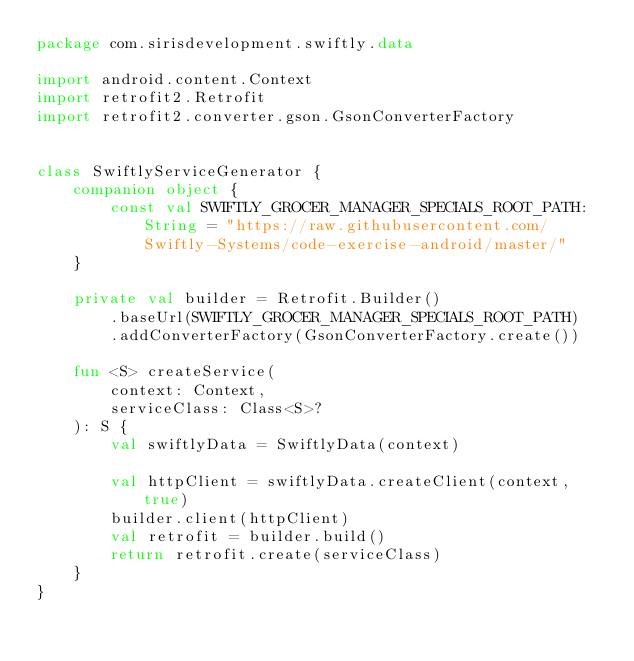Convert code to text. <code><loc_0><loc_0><loc_500><loc_500><_Kotlin_>package com.sirisdevelopment.swiftly.data

import android.content.Context
import retrofit2.Retrofit
import retrofit2.converter.gson.GsonConverterFactory


class SwiftlyServiceGenerator {
    companion object {
        const val SWIFTLY_GROCER_MANAGER_SPECIALS_ROOT_PATH: String = "https://raw.githubusercontent.com/Swiftly-Systems/code-exercise-android/master/"
    }

    private val builder = Retrofit.Builder()
        .baseUrl(SWIFTLY_GROCER_MANAGER_SPECIALS_ROOT_PATH)
        .addConverterFactory(GsonConverterFactory.create())

    fun <S> createService(
        context: Context,
        serviceClass: Class<S>?
    ): S {
        val swiftlyData = SwiftlyData(context)

        val httpClient = swiftlyData.createClient(context,  true)
        builder.client(httpClient)
        val retrofit = builder.build()
        return retrofit.create(serviceClass)
    }
}
</code> 